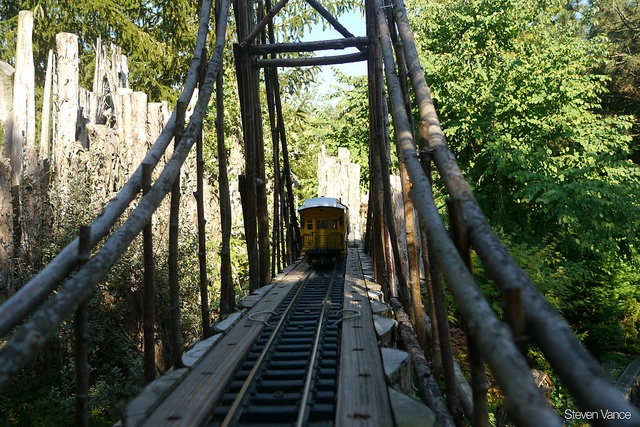Describe the objects in this image and their specific colors. I can see a train in gray, black, olive, and lightblue tones in this image. 